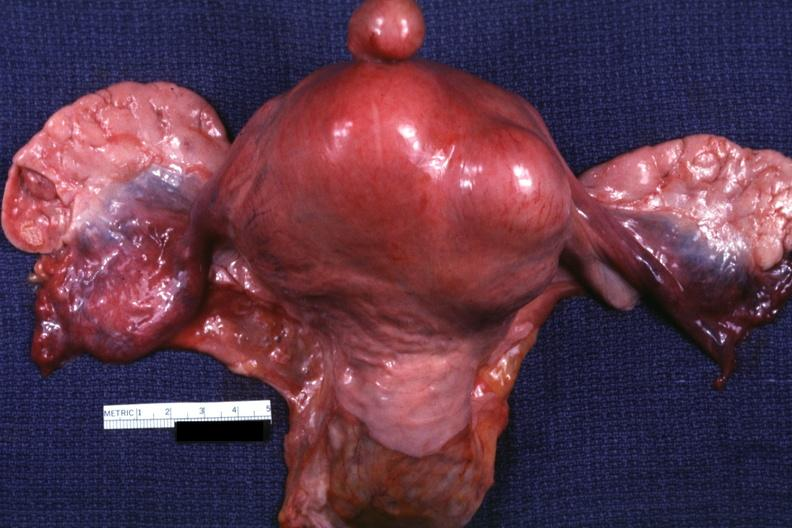how is this a example one pedunculated myoma?
Answer the question using a single word or phrase. Good 